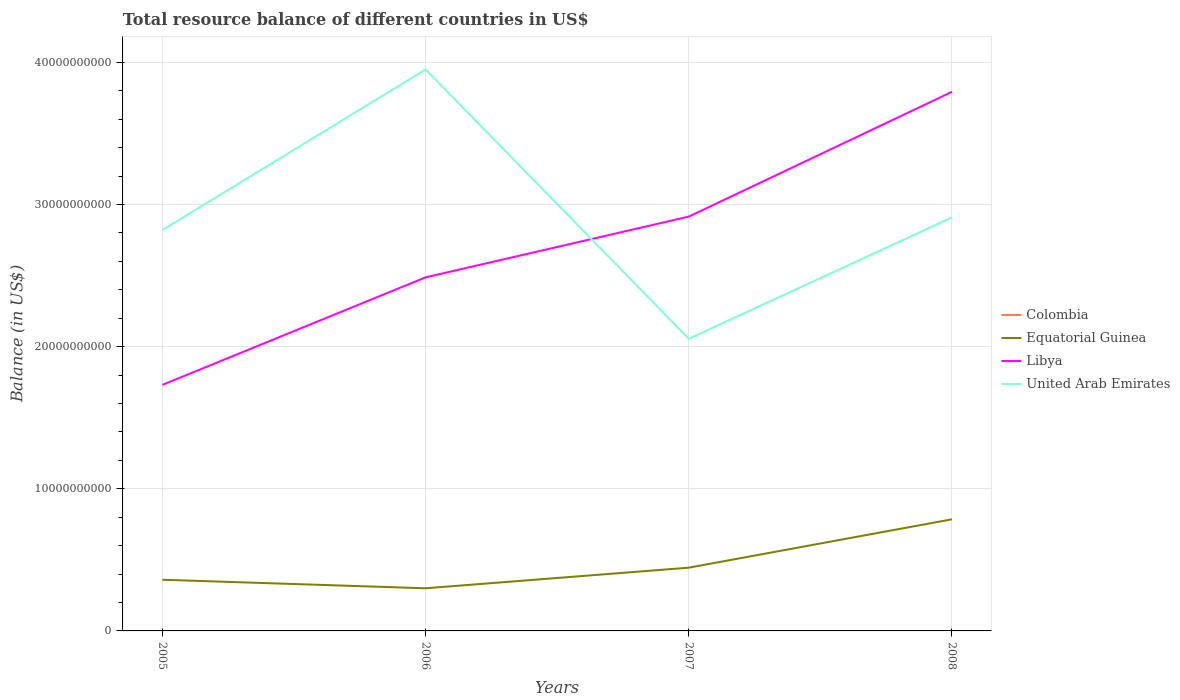How many different coloured lines are there?
Ensure brevity in your answer.  3. Across all years, what is the maximum total resource balance in United Arab Emirates?
Provide a short and direct response. 2.06e+1. What is the total total resource balance in United Arab Emirates in the graph?
Provide a short and direct response. -8.86e+08. What is the difference between the highest and the second highest total resource balance in United Arab Emirates?
Keep it short and to the point. 1.89e+1. What is the difference between the highest and the lowest total resource balance in Equatorial Guinea?
Ensure brevity in your answer.  1. How many lines are there?
Make the answer very short. 3. How many years are there in the graph?
Make the answer very short. 4. What is the difference between two consecutive major ticks on the Y-axis?
Provide a succinct answer. 1.00e+1. Are the values on the major ticks of Y-axis written in scientific E-notation?
Your response must be concise. No. Where does the legend appear in the graph?
Ensure brevity in your answer.  Center right. How are the legend labels stacked?
Keep it short and to the point. Vertical. What is the title of the graph?
Provide a succinct answer. Total resource balance of different countries in US$. Does "Cuba" appear as one of the legend labels in the graph?
Your answer should be compact. No. What is the label or title of the Y-axis?
Ensure brevity in your answer.  Balance (in US$). What is the Balance (in US$) of Equatorial Guinea in 2005?
Give a very brief answer. 3.60e+09. What is the Balance (in US$) of Libya in 2005?
Provide a succinct answer. 1.73e+1. What is the Balance (in US$) in United Arab Emirates in 2005?
Your response must be concise. 2.82e+1. What is the Balance (in US$) of Equatorial Guinea in 2006?
Give a very brief answer. 3.00e+09. What is the Balance (in US$) of Libya in 2006?
Offer a terse response. 2.49e+1. What is the Balance (in US$) in United Arab Emirates in 2006?
Offer a terse response. 3.95e+1. What is the Balance (in US$) in Equatorial Guinea in 2007?
Your response must be concise. 4.45e+09. What is the Balance (in US$) in Libya in 2007?
Your response must be concise. 2.91e+1. What is the Balance (in US$) in United Arab Emirates in 2007?
Give a very brief answer. 2.06e+1. What is the Balance (in US$) of Colombia in 2008?
Offer a terse response. 0. What is the Balance (in US$) of Equatorial Guinea in 2008?
Offer a terse response. 7.85e+09. What is the Balance (in US$) in Libya in 2008?
Ensure brevity in your answer.  3.79e+1. What is the Balance (in US$) of United Arab Emirates in 2008?
Your response must be concise. 2.91e+1. Across all years, what is the maximum Balance (in US$) in Equatorial Guinea?
Make the answer very short. 7.85e+09. Across all years, what is the maximum Balance (in US$) in Libya?
Give a very brief answer. 3.79e+1. Across all years, what is the maximum Balance (in US$) in United Arab Emirates?
Provide a succinct answer. 3.95e+1. Across all years, what is the minimum Balance (in US$) of Equatorial Guinea?
Offer a terse response. 3.00e+09. Across all years, what is the minimum Balance (in US$) in Libya?
Provide a short and direct response. 1.73e+1. Across all years, what is the minimum Balance (in US$) in United Arab Emirates?
Keep it short and to the point. 2.06e+1. What is the total Balance (in US$) in Colombia in the graph?
Make the answer very short. 0. What is the total Balance (in US$) of Equatorial Guinea in the graph?
Give a very brief answer. 1.89e+1. What is the total Balance (in US$) of Libya in the graph?
Offer a very short reply. 1.09e+11. What is the total Balance (in US$) of United Arab Emirates in the graph?
Offer a very short reply. 1.17e+11. What is the difference between the Balance (in US$) in Equatorial Guinea in 2005 and that in 2006?
Ensure brevity in your answer.  6.00e+08. What is the difference between the Balance (in US$) of Libya in 2005 and that in 2006?
Make the answer very short. -7.56e+09. What is the difference between the Balance (in US$) in United Arab Emirates in 2005 and that in 2006?
Your response must be concise. -1.13e+1. What is the difference between the Balance (in US$) in Equatorial Guinea in 2005 and that in 2007?
Keep it short and to the point. -8.50e+08. What is the difference between the Balance (in US$) in Libya in 2005 and that in 2007?
Your answer should be compact. -1.18e+1. What is the difference between the Balance (in US$) of United Arab Emirates in 2005 and that in 2007?
Your answer should be compact. 7.65e+09. What is the difference between the Balance (in US$) in Equatorial Guinea in 2005 and that in 2008?
Keep it short and to the point. -4.25e+09. What is the difference between the Balance (in US$) in Libya in 2005 and that in 2008?
Your response must be concise. -2.06e+1. What is the difference between the Balance (in US$) in United Arab Emirates in 2005 and that in 2008?
Your response must be concise. -8.86e+08. What is the difference between the Balance (in US$) in Equatorial Guinea in 2006 and that in 2007?
Your answer should be compact. -1.45e+09. What is the difference between the Balance (in US$) in Libya in 2006 and that in 2007?
Offer a terse response. -4.27e+09. What is the difference between the Balance (in US$) in United Arab Emirates in 2006 and that in 2007?
Provide a short and direct response. 1.89e+1. What is the difference between the Balance (in US$) in Equatorial Guinea in 2006 and that in 2008?
Your response must be concise. -4.85e+09. What is the difference between the Balance (in US$) of Libya in 2006 and that in 2008?
Provide a succinct answer. -1.31e+1. What is the difference between the Balance (in US$) in United Arab Emirates in 2006 and that in 2008?
Provide a succinct answer. 1.04e+1. What is the difference between the Balance (in US$) of Equatorial Guinea in 2007 and that in 2008?
Keep it short and to the point. -3.40e+09. What is the difference between the Balance (in US$) in Libya in 2007 and that in 2008?
Offer a terse response. -8.78e+09. What is the difference between the Balance (in US$) in United Arab Emirates in 2007 and that in 2008?
Keep it short and to the point. -8.54e+09. What is the difference between the Balance (in US$) in Equatorial Guinea in 2005 and the Balance (in US$) in Libya in 2006?
Give a very brief answer. -2.13e+1. What is the difference between the Balance (in US$) of Equatorial Guinea in 2005 and the Balance (in US$) of United Arab Emirates in 2006?
Provide a short and direct response. -3.59e+1. What is the difference between the Balance (in US$) of Libya in 2005 and the Balance (in US$) of United Arab Emirates in 2006?
Keep it short and to the point. -2.22e+1. What is the difference between the Balance (in US$) of Equatorial Guinea in 2005 and the Balance (in US$) of Libya in 2007?
Offer a very short reply. -2.55e+1. What is the difference between the Balance (in US$) in Equatorial Guinea in 2005 and the Balance (in US$) in United Arab Emirates in 2007?
Make the answer very short. -1.70e+1. What is the difference between the Balance (in US$) of Libya in 2005 and the Balance (in US$) of United Arab Emirates in 2007?
Your response must be concise. -3.24e+09. What is the difference between the Balance (in US$) in Equatorial Guinea in 2005 and the Balance (in US$) in Libya in 2008?
Ensure brevity in your answer.  -3.43e+1. What is the difference between the Balance (in US$) of Equatorial Guinea in 2005 and the Balance (in US$) of United Arab Emirates in 2008?
Your answer should be compact. -2.55e+1. What is the difference between the Balance (in US$) in Libya in 2005 and the Balance (in US$) in United Arab Emirates in 2008?
Give a very brief answer. -1.18e+1. What is the difference between the Balance (in US$) of Equatorial Guinea in 2006 and the Balance (in US$) of Libya in 2007?
Keep it short and to the point. -2.61e+1. What is the difference between the Balance (in US$) of Equatorial Guinea in 2006 and the Balance (in US$) of United Arab Emirates in 2007?
Provide a succinct answer. -1.76e+1. What is the difference between the Balance (in US$) in Libya in 2006 and the Balance (in US$) in United Arab Emirates in 2007?
Offer a terse response. 4.32e+09. What is the difference between the Balance (in US$) of Equatorial Guinea in 2006 and the Balance (in US$) of Libya in 2008?
Keep it short and to the point. -3.49e+1. What is the difference between the Balance (in US$) in Equatorial Guinea in 2006 and the Balance (in US$) in United Arab Emirates in 2008?
Ensure brevity in your answer.  -2.61e+1. What is the difference between the Balance (in US$) in Libya in 2006 and the Balance (in US$) in United Arab Emirates in 2008?
Your answer should be very brief. -4.22e+09. What is the difference between the Balance (in US$) of Equatorial Guinea in 2007 and the Balance (in US$) of Libya in 2008?
Provide a short and direct response. -3.35e+1. What is the difference between the Balance (in US$) in Equatorial Guinea in 2007 and the Balance (in US$) in United Arab Emirates in 2008?
Your answer should be very brief. -2.46e+1. What is the difference between the Balance (in US$) of Libya in 2007 and the Balance (in US$) of United Arab Emirates in 2008?
Keep it short and to the point. 5.56e+07. What is the average Balance (in US$) in Equatorial Guinea per year?
Provide a short and direct response. 4.73e+09. What is the average Balance (in US$) in Libya per year?
Offer a terse response. 2.73e+1. What is the average Balance (in US$) of United Arab Emirates per year?
Keep it short and to the point. 2.93e+1. In the year 2005, what is the difference between the Balance (in US$) in Equatorial Guinea and Balance (in US$) in Libya?
Offer a terse response. -1.37e+1. In the year 2005, what is the difference between the Balance (in US$) of Equatorial Guinea and Balance (in US$) of United Arab Emirates?
Ensure brevity in your answer.  -2.46e+1. In the year 2005, what is the difference between the Balance (in US$) of Libya and Balance (in US$) of United Arab Emirates?
Provide a succinct answer. -1.09e+1. In the year 2006, what is the difference between the Balance (in US$) in Equatorial Guinea and Balance (in US$) in Libya?
Provide a succinct answer. -2.19e+1. In the year 2006, what is the difference between the Balance (in US$) of Equatorial Guinea and Balance (in US$) of United Arab Emirates?
Your response must be concise. -3.65e+1. In the year 2006, what is the difference between the Balance (in US$) of Libya and Balance (in US$) of United Arab Emirates?
Keep it short and to the point. -1.46e+1. In the year 2007, what is the difference between the Balance (in US$) in Equatorial Guinea and Balance (in US$) in Libya?
Offer a terse response. -2.47e+1. In the year 2007, what is the difference between the Balance (in US$) in Equatorial Guinea and Balance (in US$) in United Arab Emirates?
Your answer should be compact. -1.61e+1. In the year 2007, what is the difference between the Balance (in US$) in Libya and Balance (in US$) in United Arab Emirates?
Keep it short and to the point. 8.59e+09. In the year 2008, what is the difference between the Balance (in US$) in Equatorial Guinea and Balance (in US$) in Libya?
Provide a succinct answer. -3.01e+1. In the year 2008, what is the difference between the Balance (in US$) of Equatorial Guinea and Balance (in US$) of United Arab Emirates?
Your answer should be very brief. -2.12e+1. In the year 2008, what is the difference between the Balance (in US$) of Libya and Balance (in US$) of United Arab Emirates?
Offer a terse response. 8.83e+09. What is the ratio of the Balance (in US$) of Equatorial Guinea in 2005 to that in 2006?
Make the answer very short. 1.2. What is the ratio of the Balance (in US$) of Libya in 2005 to that in 2006?
Provide a succinct answer. 0.7. What is the ratio of the Balance (in US$) of United Arab Emirates in 2005 to that in 2006?
Provide a succinct answer. 0.71. What is the ratio of the Balance (in US$) in Equatorial Guinea in 2005 to that in 2007?
Your response must be concise. 0.81. What is the ratio of the Balance (in US$) of Libya in 2005 to that in 2007?
Provide a succinct answer. 0.59. What is the ratio of the Balance (in US$) of United Arab Emirates in 2005 to that in 2007?
Provide a succinct answer. 1.37. What is the ratio of the Balance (in US$) in Equatorial Guinea in 2005 to that in 2008?
Provide a short and direct response. 0.46. What is the ratio of the Balance (in US$) of Libya in 2005 to that in 2008?
Your answer should be very brief. 0.46. What is the ratio of the Balance (in US$) of United Arab Emirates in 2005 to that in 2008?
Provide a short and direct response. 0.97. What is the ratio of the Balance (in US$) in Equatorial Guinea in 2006 to that in 2007?
Ensure brevity in your answer.  0.67. What is the ratio of the Balance (in US$) of Libya in 2006 to that in 2007?
Provide a succinct answer. 0.85. What is the ratio of the Balance (in US$) in United Arab Emirates in 2006 to that in 2007?
Provide a short and direct response. 1.92. What is the ratio of the Balance (in US$) in Equatorial Guinea in 2006 to that in 2008?
Your response must be concise. 0.38. What is the ratio of the Balance (in US$) in Libya in 2006 to that in 2008?
Your answer should be compact. 0.66. What is the ratio of the Balance (in US$) of United Arab Emirates in 2006 to that in 2008?
Your response must be concise. 1.36. What is the ratio of the Balance (in US$) of Equatorial Guinea in 2007 to that in 2008?
Keep it short and to the point. 0.57. What is the ratio of the Balance (in US$) of Libya in 2007 to that in 2008?
Your answer should be very brief. 0.77. What is the ratio of the Balance (in US$) of United Arab Emirates in 2007 to that in 2008?
Provide a short and direct response. 0.71. What is the difference between the highest and the second highest Balance (in US$) of Equatorial Guinea?
Offer a terse response. 3.40e+09. What is the difference between the highest and the second highest Balance (in US$) of Libya?
Offer a terse response. 8.78e+09. What is the difference between the highest and the second highest Balance (in US$) in United Arab Emirates?
Offer a very short reply. 1.04e+1. What is the difference between the highest and the lowest Balance (in US$) of Equatorial Guinea?
Offer a very short reply. 4.85e+09. What is the difference between the highest and the lowest Balance (in US$) of Libya?
Your answer should be compact. 2.06e+1. What is the difference between the highest and the lowest Balance (in US$) in United Arab Emirates?
Ensure brevity in your answer.  1.89e+1. 